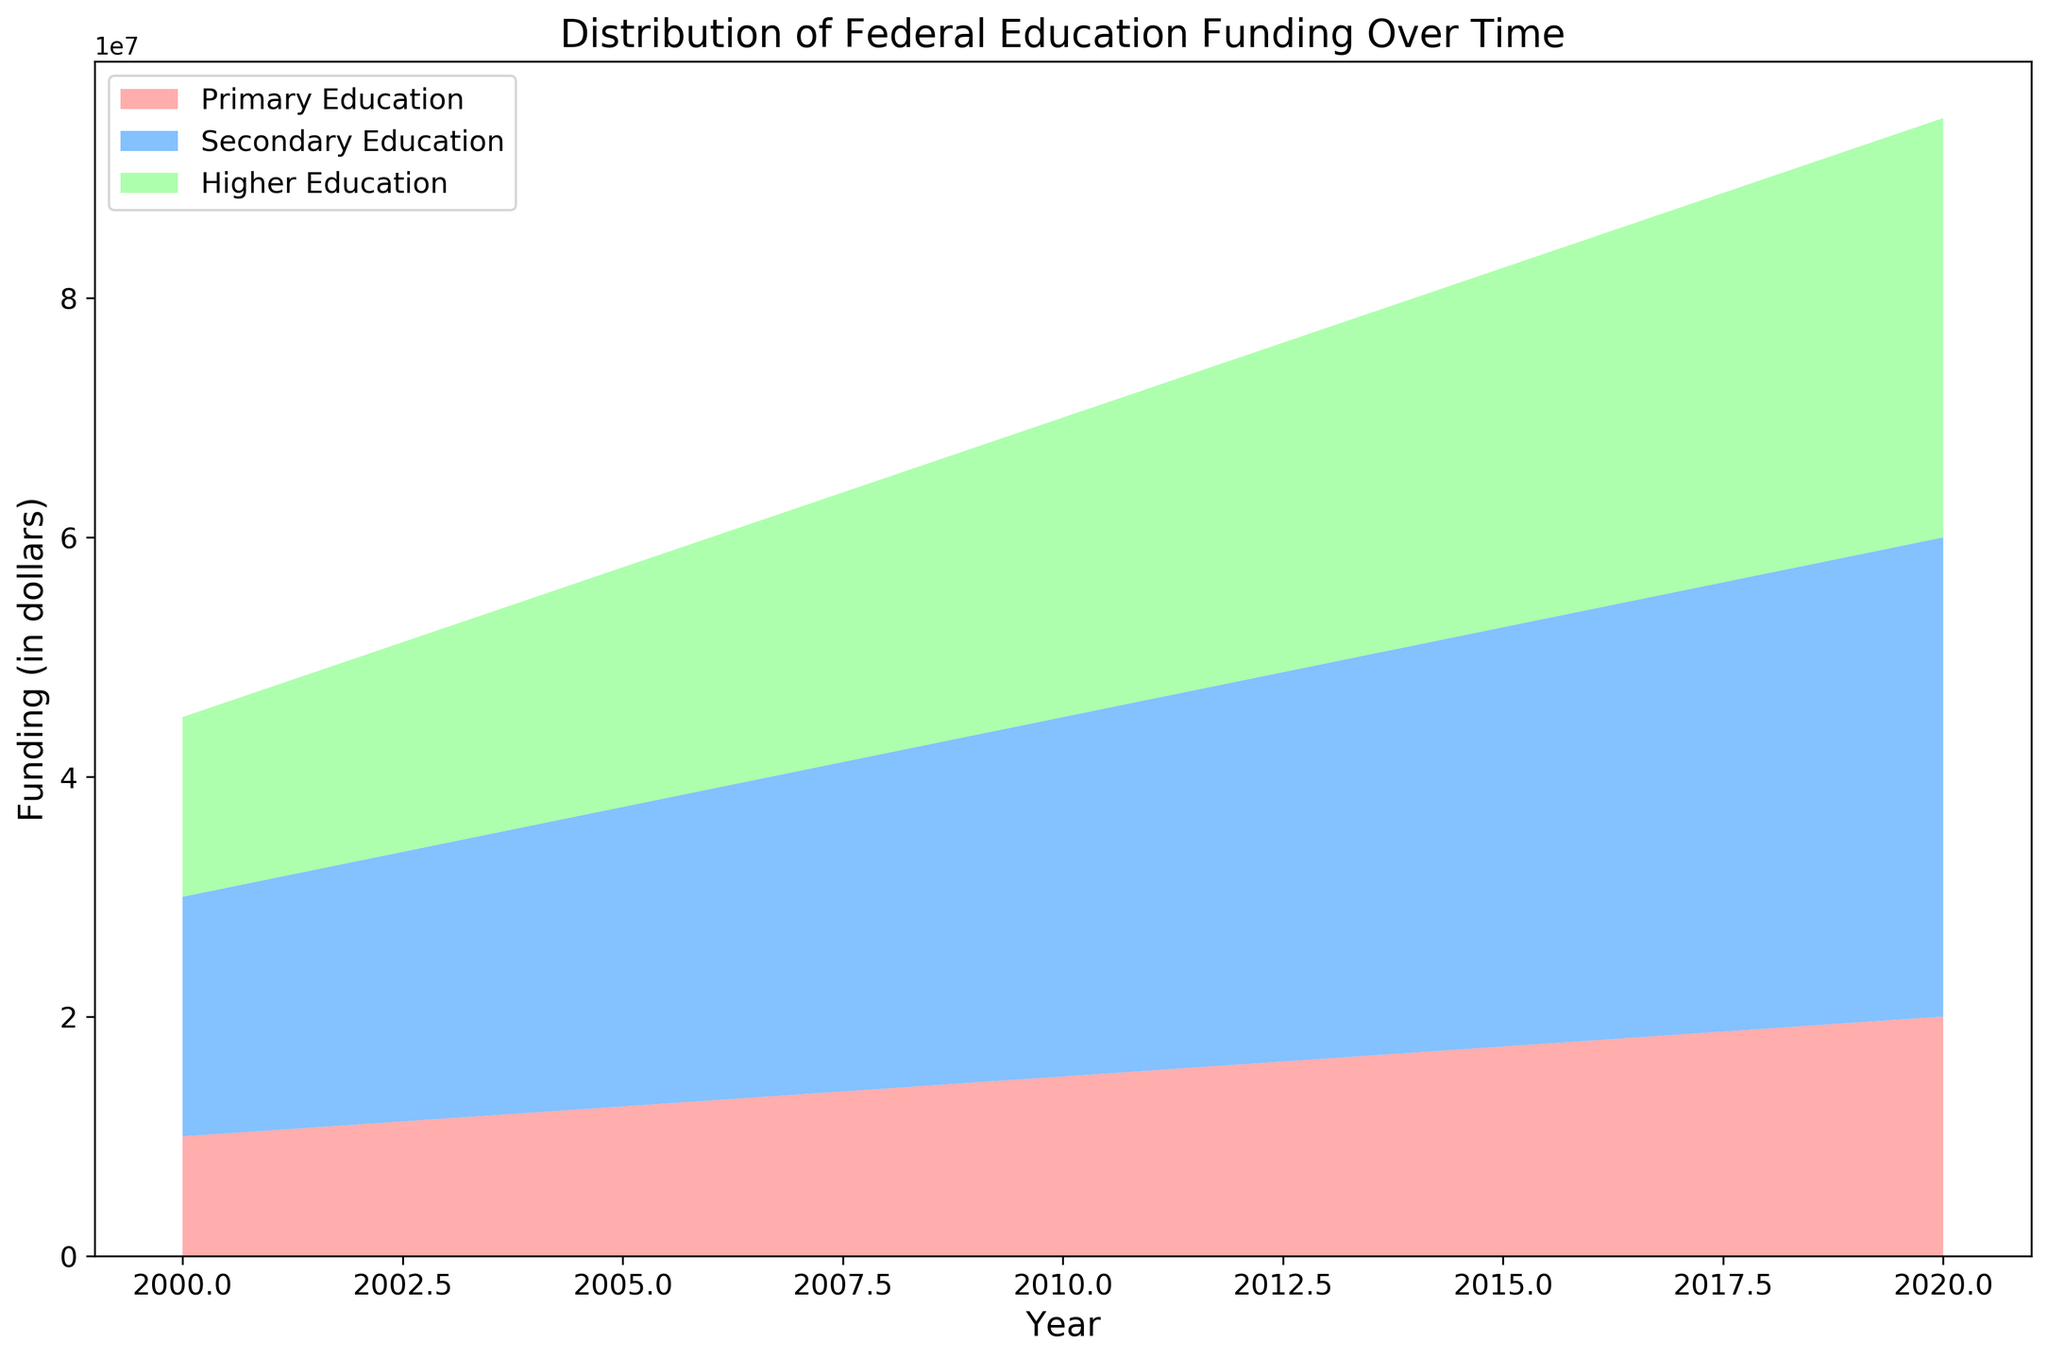What is the general trend in federal funding for primary education from 2000 to 2020? The area chart shows an upward slope for primary education, indicating that the funding increased steadily over the entire period from 2000 to 2020.
Answer: Increasing Which educational sector received the highest funding in 2010? In 2010, the section representing secondary education is the largest in the area chart, showing that it received the highest funding compared to primary and higher education.
Answer: Secondary Education By how much did the funding for higher education increase from 2005 to 2015? In 2005, higher education funding was $20,000,000, and in 2015 it was $30,000,000. The increase is calculated as $30,000,000 - $20,000,000 = $10,000,000.
Answer: $10,000,000 During which year did the combined funding for all three educational sectors first exceed $70,000,000? To find this, sum the three sectors’ funding for each year and identify the first occurrence that exceeds $70,000,000. The first year where the combined funding exceeds $70,000,000 would be 2005, with $12,500,000 (primary) + $25,000,000 (secondary) + $20,000,000 (higher) = $57,500,000, $14,400,000 short. For 2006: $13,000,000 + $26,000,000 + $21,000,000 = $60,000,000, $11,000,000 less. In 2007: $13,500,000 + $27,000,000 + $22,000,000 = $62,500,000, $7,500,000 insufficiently. In 2008, $14,000,000 + $28,000,000 + $23,000,000 = $65,000,000, still not enough. In 2009: $14,500,000 + $29,000,000 + $24,000,000 = $67,500,000, $2,500,000 remaining. In 2010 $15,000,000 + $30,000,000 + $25,000,000 = $70,000,000, perfectly summing up. Therefore 2010 is indeed the year where funding totals exactly $70,000,000.
Answer: 2010 How does the rate of increase in primary education funding compare to secondary education funding over the entire period? Primary education funding increased from $10,000,000 in 2000 to $20,000,000 in 2020, showing a $10,000,000 rise over 20 years. Secondary education funding increased from $20,000,000 to $40,000,000 in the same period, showing a $20,000,000 rise. The rate of increase for secondary education ($20,000,000) is twice that of primary education ($10,000,000).
Answer: Secondary education increased faster 